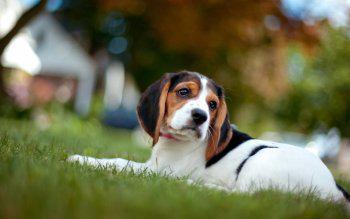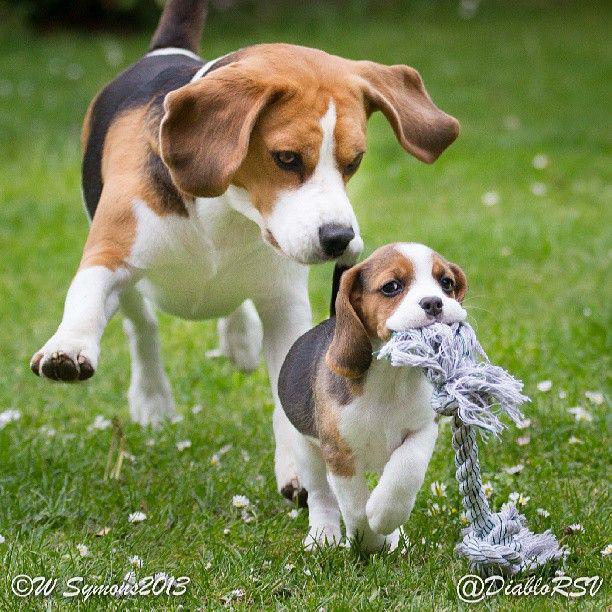The first image is the image on the left, the second image is the image on the right. For the images shown, is this caption "A dog in one image has a toy in his mouth." true? Answer yes or no. Yes. 